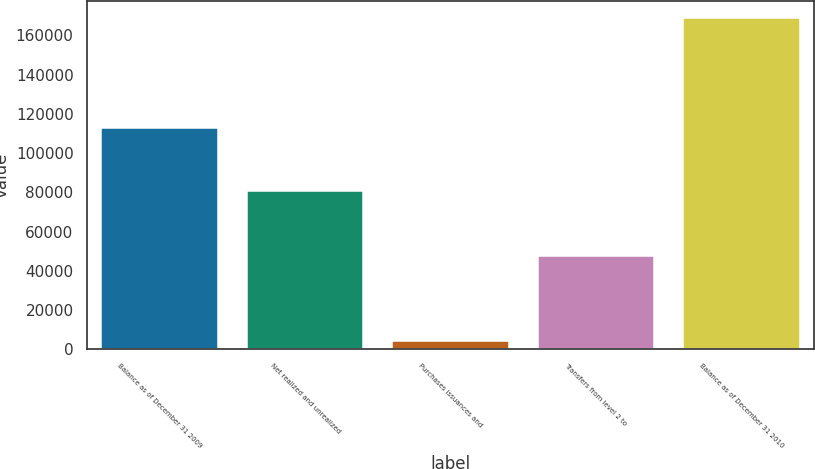<chart> <loc_0><loc_0><loc_500><loc_500><bar_chart><fcel>Balance as of December 31 2009<fcel>Net realized and unrealized<fcel>Purchases issuances and<fcel>Transfers from level 2 to<fcel>Balance as of December 31 2010<nl><fcel>113011<fcel>80664.6<fcel>4085<fcel>47683<fcel>168993<nl></chart> 